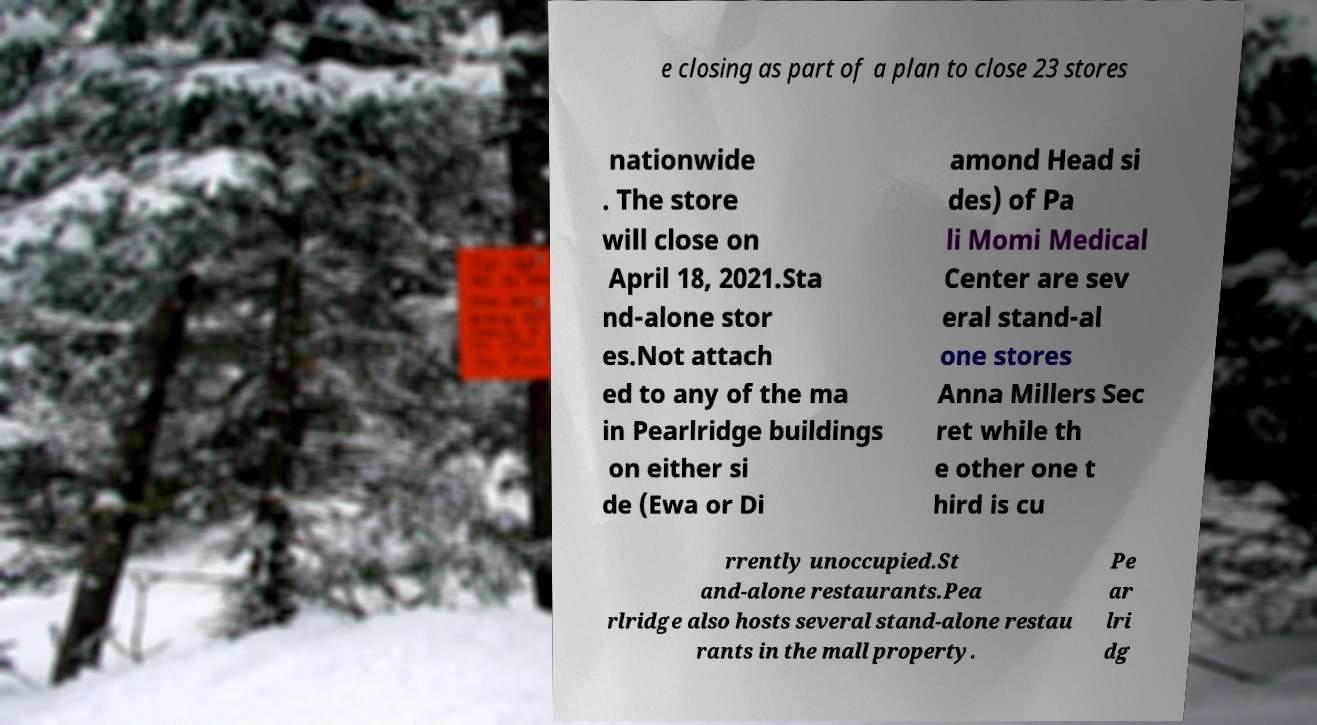Could you extract and type out the text from this image? e closing as part of a plan to close 23 stores nationwide . The store will close on April 18, 2021.Sta nd-alone stor es.Not attach ed to any of the ma in Pearlridge buildings on either si de (Ewa or Di amond Head si des) of Pa li Momi Medical Center are sev eral stand-al one stores Anna Millers Sec ret while th e other one t hird is cu rrently unoccupied.St and-alone restaurants.Pea rlridge also hosts several stand-alone restau rants in the mall property. Pe ar lri dg 